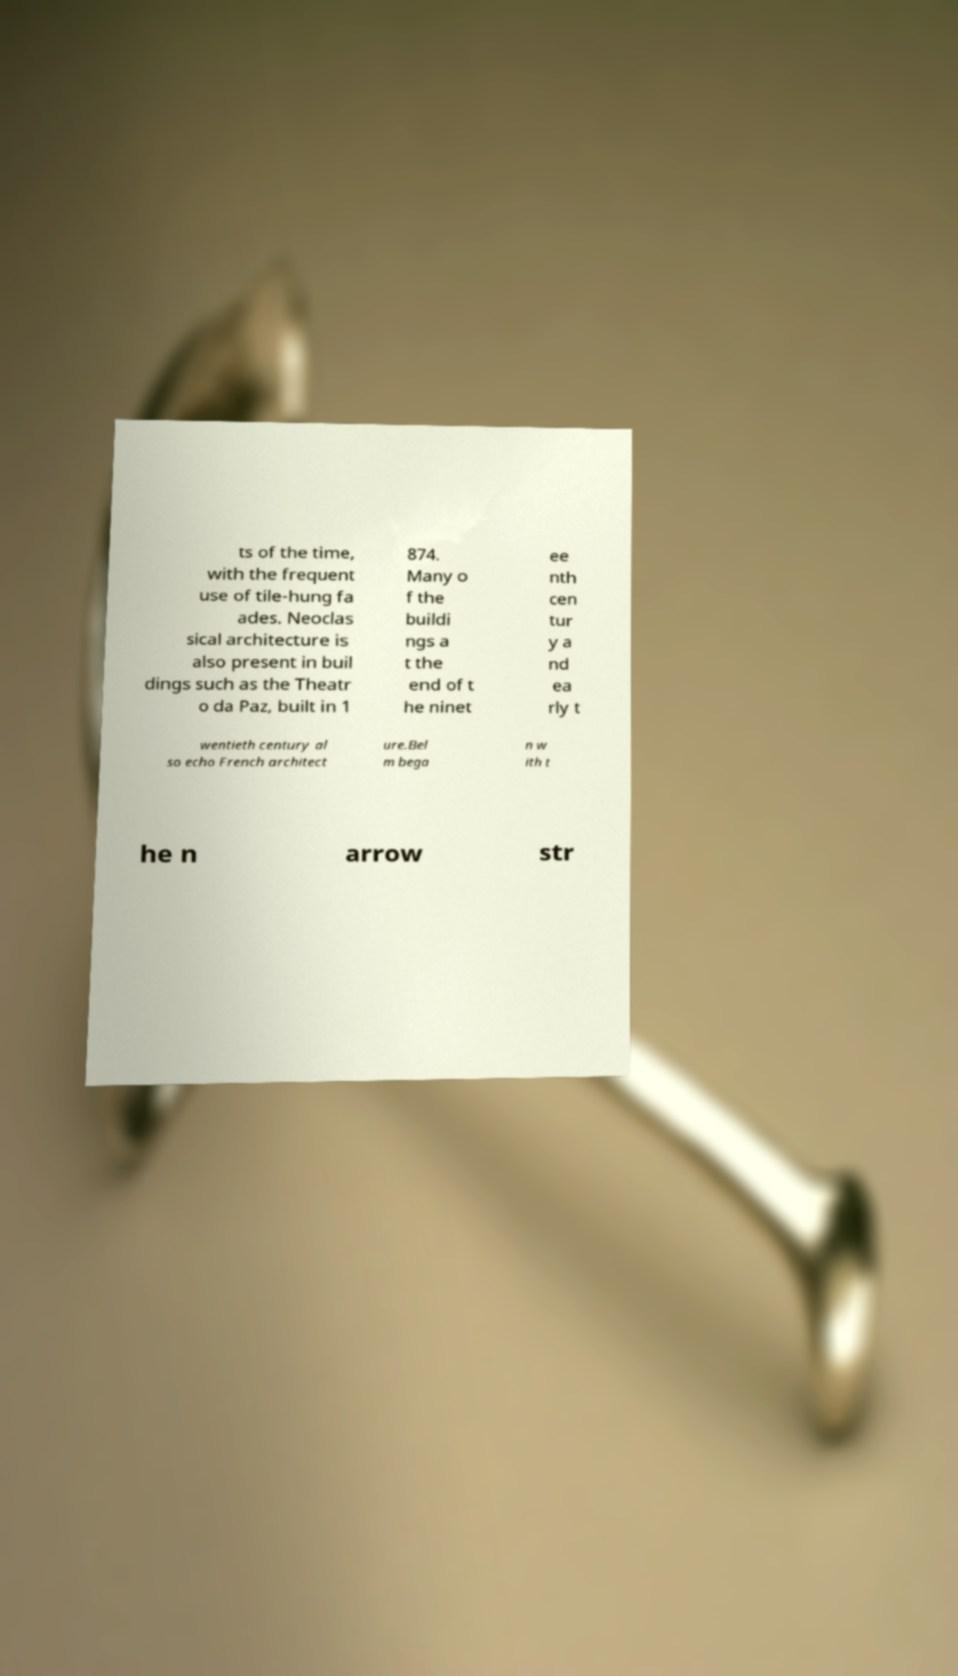Could you extract and type out the text from this image? ts of the time, with the frequent use of tile-hung fa ades. Neoclas sical architecture is also present in buil dings such as the Theatr o da Paz, built in 1 874. Many o f the buildi ngs a t the end of t he ninet ee nth cen tur y a nd ea rly t wentieth century al so echo French architect ure.Bel m bega n w ith t he n arrow str 